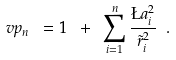<formula> <loc_0><loc_0><loc_500><loc_500>\ v p _ { n } \ = 1 \ + \ \sum _ { i = 1 } ^ { n } \frac { \L a _ { i } ^ { 2 } } { \tilde { r } _ { i } ^ { 2 } } \ .</formula> 